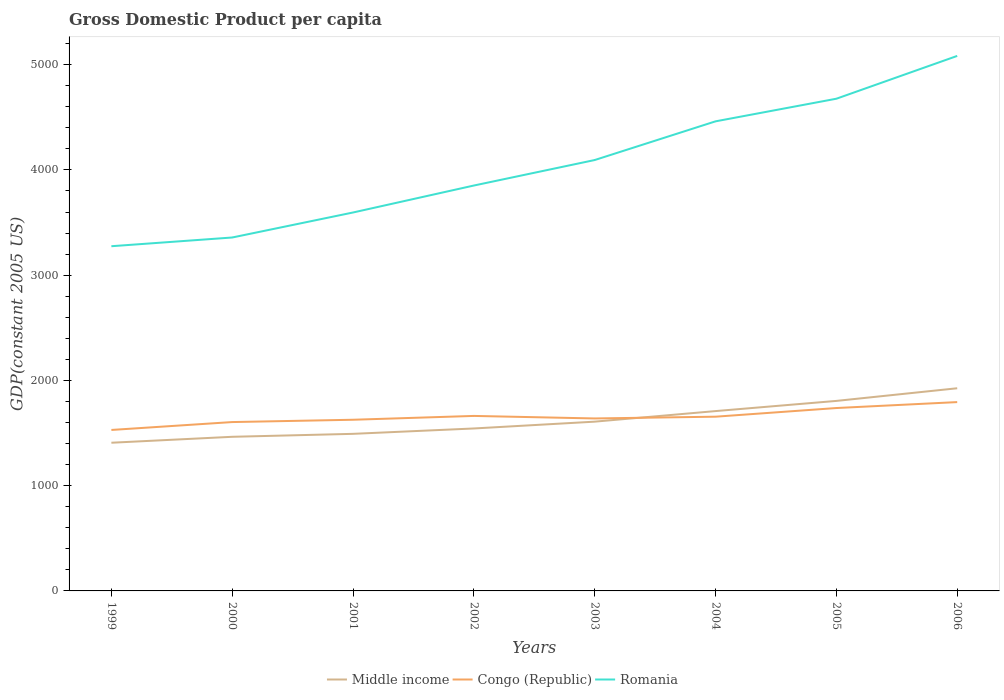Is the number of lines equal to the number of legend labels?
Your answer should be very brief. Yes. Across all years, what is the maximum GDP per capita in Middle income?
Ensure brevity in your answer.  1407.97. In which year was the GDP per capita in Congo (Republic) maximum?
Ensure brevity in your answer.  1999. What is the total GDP per capita in Congo (Republic) in the graph?
Provide a succinct answer. -264.66. What is the difference between the highest and the second highest GDP per capita in Middle income?
Ensure brevity in your answer.  517.51. What is the difference between the highest and the lowest GDP per capita in Middle income?
Offer a very short reply. 3. What is the difference between two consecutive major ticks on the Y-axis?
Provide a short and direct response. 1000. Are the values on the major ticks of Y-axis written in scientific E-notation?
Your answer should be compact. No. Does the graph contain any zero values?
Your answer should be very brief. No. Where does the legend appear in the graph?
Provide a short and direct response. Bottom center. How many legend labels are there?
Give a very brief answer. 3. What is the title of the graph?
Offer a very short reply. Gross Domestic Product per capita. Does "American Samoa" appear as one of the legend labels in the graph?
Provide a short and direct response. No. What is the label or title of the Y-axis?
Your answer should be compact. GDP(constant 2005 US). What is the GDP(constant 2005 US) in Middle income in 1999?
Your answer should be very brief. 1407.97. What is the GDP(constant 2005 US) of Congo (Republic) in 1999?
Your answer should be compact. 1529.32. What is the GDP(constant 2005 US) of Romania in 1999?
Make the answer very short. 3275.03. What is the GDP(constant 2005 US) of Middle income in 2000?
Your response must be concise. 1464.33. What is the GDP(constant 2005 US) in Congo (Republic) in 2000?
Offer a very short reply. 1604.28. What is the GDP(constant 2005 US) in Romania in 2000?
Give a very brief answer. 3357.81. What is the GDP(constant 2005 US) of Middle income in 2001?
Ensure brevity in your answer.  1492.45. What is the GDP(constant 2005 US) of Congo (Republic) in 2001?
Make the answer very short. 1626.26. What is the GDP(constant 2005 US) of Romania in 2001?
Your answer should be very brief. 3595.4. What is the GDP(constant 2005 US) in Middle income in 2002?
Offer a terse response. 1543.39. What is the GDP(constant 2005 US) in Congo (Republic) in 2002?
Make the answer very short. 1662.66. What is the GDP(constant 2005 US) in Romania in 2002?
Ensure brevity in your answer.  3851.67. What is the GDP(constant 2005 US) in Middle income in 2003?
Provide a succinct answer. 1608.23. What is the GDP(constant 2005 US) in Congo (Republic) in 2003?
Provide a short and direct response. 1638.6. What is the GDP(constant 2005 US) of Romania in 2003?
Your answer should be compact. 4093.86. What is the GDP(constant 2005 US) in Middle income in 2004?
Keep it short and to the point. 1708.59. What is the GDP(constant 2005 US) of Congo (Republic) in 2004?
Keep it short and to the point. 1655.31. What is the GDP(constant 2005 US) of Romania in 2004?
Offer a very short reply. 4461.4. What is the GDP(constant 2005 US) of Middle income in 2005?
Provide a succinct answer. 1805.33. What is the GDP(constant 2005 US) in Congo (Republic) in 2005?
Make the answer very short. 1737.61. What is the GDP(constant 2005 US) of Romania in 2005?
Give a very brief answer. 4676.32. What is the GDP(constant 2005 US) of Middle income in 2006?
Your response must be concise. 1925.47. What is the GDP(constant 2005 US) in Congo (Republic) in 2006?
Make the answer very short. 1793.98. What is the GDP(constant 2005 US) in Romania in 2006?
Offer a terse response. 5083.04. Across all years, what is the maximum GDP(constant 2005 US) of Middle income?
Provide a succinct answer. 1925.47. Across all years, what is the maximum GDP(constant 2005 US) in Congo (Republic)?
Offer a terse response. 1793.98. Across all years, what is the maximum GDP(constant 2005 US) of Romania?
Ensure brevity in your answer.  5083.04. Across all years, what is the minimum GDP(constant 2005 US) of Middle income?
Provide a succinct answer. 1407.97. Across all years, what is the minimum GDP(constant 2005 US) of Congo (Republic)?
Offer a terse response. 1529.32. Across all years, what is the minimum GDP(constant 2005 US) in Romania?
Make the answer very short. 3275.03. What is the total GDP(constant 2005 US) in Middle income in the graph?
Offer a very short reply. 1.30e+04. What is the total GDP(constant 2005 US) of Congo (Republic) in the graph?
Provide a short and direct response. 1.32e+04. What is the total GDP(constant 2005 US) of Romania in the graph?
Provide a succinct answer. 3.24e+04. What is the difference between the GDP(constant 2005 US) in Middle income in 1999 and that in 2000?
Your response must be concise. -56.36. What is the difference between the GDP(constant 2005 US) of Congo (Republic) in 1999 and that in 2000?
Offer a terse response. -74.96. What is the difference between the GDP(constant 2005 US) of Romania in 1999 and that in 2000?
Your answer should be compact. -82.78. What is the difference between the GDP(constant 2005 US) in Middle income in 1999 and that in 2001?
Offer a terse response. -84.48. What is the difference between the GDP(constant 2005 US) in Congo (Republic) in 1999 and that in 2001?
Ensure brevity in your answer.  -96.94. What is the difference between the GDP(constant 2005 US) in Romania in 1999 and that in 2001?
Your answer should be very brief. -320.38. What is the difference between the GDP(constant 2005 US) in Middle income in 1999 and that in 2002?
Ensure brevity in your answer.  -135.42. What is the difference between the GDP(constant 2005 US) of Congo (Republic) in 1999 and that in 2002?
Your response must be concise. -133.34. What is the difference between the GDP(constant 2005 US) in Romania in 1999 and that in 2002?
Ensure brevity in your answer.  -576.64. What is the difference between the GDP(constant 2005 US) in Middle income in 1999 and that in 2003?
Keep it short and to the point. -200.26. What is the difference between the GDP(constant 2005 US) in Congo (Republic) in 1999 and that in 2003?
Your answer should be compact. -109.28. What is the difference between the GDP(constant 2005 US) in Romania in 1999 and that in 2003?
Ensure brevity in your answer.  -818.84. What is the difference between the GDP(constant 2005 US) in Middle income in 1999 and that in 2004?
Make the answer very short. -300.63. What is the difference between the GDP(constant 2005 US) in Congo (Republic) in 1999 and that in 2004?
Provide a succinct answer. -125.99. What is the difference between the GDP(constant 2005 US) of Romania in 1999 and that in 2004?
Make the answer very short. -1186.37. What is the difference between the GDP(constant 2005 US) in Middle income in 1999 and that in 2005?
Provide a short and direct response. -397.36. What is the difference between the GDP(constant 2005 US) in Congo (Republic) in 1999 and that in 2005?
Your response must be concise. -208.29. What is the difference between the GDP(constant 2005 US) in Romania in 1999 and that in 2005?
Your response must be concise. -1401.29. What is the difference between the GDP(constant 2005 US) in Middle income in 1999 and that in 2006?
Your answer should be compact. -517.51. What is the difference between the GDP(constant 2005 US) of Congo (Republic) in 1999 and that in 2006?
Keep it short and to the point. -264.66. What is the difference between the GDP(constant 2005 US) of Romania in 1999 and that in 2006?
Your answer should be compact. -1808.01. What is the difference between the GDP(constant 2005 US) in Middle income in 2000 and that in 2001?
Keep it short and to the point. -28.12. What is the difference between the GDP(constant 2005 US) of Congo (Republic) in 2000 and that in 2001?
Give a very brief answer. -21.98. What is the difference between the GDP(constant 2005 US) of Romania in 2000 and that in 2001?
Make the answer very short. -237.59. What is the difference between the GDP(constant 2005 US) of Middle income in 2000 and that in 2002?
Your answer should be very brief. -79.06. What is the difference between the GDP(constant 2005 US) of Congo (Republic) in 2000 and that in 2002?
Your answer should be very brief. -58.38. What is the difference between the GDP(constant 2005 US) of Romania in 2000 and that in 2002?
Make the answer very short. -493.85. What is the difference between the GDP(constant 2005 US) in Middle income in 2000 and that in 2003?
Offer a very short reply. -143.9. What is the difference between the GDP(constant 2005 US) in Congo (Republic) in 2000 and that in 2003?
Make the answer very short. -34.32. What is the difference between the GDP(constant 2005 US) of Romania in 2000 and that in 2003?
Offer a very short reply. -736.05. What is the difference between the GDP(constant 2005 US) of Middle income in 2000 and that in 2004?
Keep it short and to the point. -244.26. What is the difference between the GDP(constant 2005 US) of Congo (Republic) in 2000 and that in 2004?
Ensure brevity in your answer.  -51.03. What is the difference between the GDP(constant 2005 US) of Romania in 2000 and that in 2004?
Your response must be concise. -1103.59. What is the difference between the GDP(constant 2005 US) in Middle income in 2000 and that in 2005?
Ensure brevity in your answer.  -341. What is the difference between the GDP(constant 2005 US) in Congo (Republic) in 2000 and that in 2005?
Offer a very short reply. -133.33. What is the difference between the GDP(constant 2005 US) in Romania in 2000 and that in 2005?
Make the answer very short. -1318.5. What is the difference between the GDP(constant 2005 US) of Middle income in 2000 and that in 2006?
Give a very brief answer. -461.14. What is the difference between the GDP(constant 2005 US) in Congo (Republic) in 2000 and that in 2006?
Keep it short and to the point. -189.7. What is the difference between the GDP(constant 2005 US) of Romania in 2000 and that in 2006?
Offer a very short reply. -1725.23. What is the difference between the GDP(constant 2005 US) in Middle income in 2001 and that in 2002?
Keep it short and to the point. -50.94. What is the difference between the GDP(constant 2005 US) in Congo (Republic) in 2001 and that in 2002?
Your answer should be compact. -36.4. What is the difference between the GDP(constant 2005 US) of Romania in 2001 and that in 2002?
Provide a short and direct response. -256.26. What is the difference between the GDP(constant 2005 US) in Middle income in 2001 and that in 2003?
Your answer should be compact. -115.78. What is the difference between the GDP(constant 2005 US) of Congo (Republic) in 2001 and that in 2003?
Ensure brevity in your answer.  -12.34. What is the difference between the GDP(constant 2005 US) in Romania in 2001 and that in 2003?
Provide a succinct answer. -498.46. What is the difference between the GDP(constant 2005 US) of Middle income in 2001 and that in 2004?
Provide a short and direct response. -216.15. What is the difference between the GDP(constant 2005 US) in Congo (Republic) in 2001 and that in 2004?
Your response must be concise. -29.05. What is the difference between the GDP(constant 2005 US) in Romania in 2001 and that in 2004?
Your answer should be very brief. -866. What is the difference between the GDP(constant 2005 US) in Middle income in 2001 and that in 2005?
Offer a terse response. -312.88. What is the difference between the GDP(constant 2005 US) of Congo (Republic) in 2001 and that in 2005?
Offer a terse response. -111.35. What is the difference between the GDP(constant 2005 US) in Romania in 2001 and that in 2005?
Provide a short and direct response. -1080.91. What is the difference between the GDP(constant 2005 US) in Middle income in 2001 and that in 2006?
Your answer should be very brief. -433.02. What is the difference between the GDP(constant 2005 US) in Congo (Republic) in 2001 and that in 2006?
Offer a terse response. -167.73. What is the difference between the GDP(constant 2005 US) of Romania in 2001 and that in 2006?
Your response must be concise. -1487.64. What is the difference between the GDP(constant 2005 US) of Middle income in 2002 and that in 2003?
Your response must be concise. -64.84. What is the difference between the GDP(constant 2005 US) of Congo (Republic) in 2002 and that in 2003?
Provide a short and direct response. 24.06. What is the difference between the GDP(constant 2005 US) of Romania in 2002 and that in 2003?
Ensure brevity in your answer.  -242.2. What is the difference between the GDP(constant 2005 US) of Middle income in 2002 and that in 2004?
Your answer should be very brief. -165.2. What is the difference between the GDP(constant 2005 US) in Congo (Republic) in 2002 and that in 2004?
Provide a succinct answer. 7.35. What is the difference between the GDP(constant 2005 US) of Romania in 2002 and that in 2004?
Give a very brief answer. -609.74. What is the difference between the GDP(constant 2005 US) of Middle income in 2002 and that in 2005?
Give a very brief answer. -261.94. What is the difference between the GDP(constant 2005 US) of Congo (Republic) in 2002 and that in 2005?
Provide a succinct answer. -74.95. What is the difference between the GDP(constant 2005 US) in Romania in 2002 and that in 2005?
Your answer should be very brief. -824.65. What is the difference between the GDP(constant 2005 US) in Middle income in 2002 and that in 2006?
Provide a succinct answer. -382.08. What is the difference between the GDP(constant 2005 US) in Congo (Republic) in 2002 and that in 2006?
Make the answer very short. -131.33. What is the difference between the GDP(constant 2005 US) in Romania in 2002 and that in 2006?
Ensure brevity in your answer.  -1231.38. What is the difference between the GDP(constant 2005 US) in Middle income in 2003 and that in 2004?
Your answer should be very brief. -100.36. What is the difference between the GDP(constant 2005 US) in Congo (Republic) in 2003 and that in 2004?
Your answer should be very brief. -16.71. What is the difference between the GDP(constant 2005 US) in Romania in 2003 and that in 2004?
Your answer should be compact. -367.54. What is the difference between the GDP(constant 2005 US) in Middle income in 2003 and that in 2005?
Make the answer very short. -197.1. What is the difference between the GDP(constant 2005 US) in Congo (Republic) in 2003 and that in 2005?
Your answer should be compact. -99.01. What is the difference between the GDP(constant 2005 US) of Romania in 2003 and that in 2005?
Your answer should be very brief. -582.45. What is the difference between the GDP(constant 2005 US) in Middle income in 2003 and that in 2006?
Give a very brief answer. -317.24. What is the difference between the GDP(constant 2005 US) of Congo (Republic) in 2003 and that in 2006?
Make the answer very short. -155.39. What is the difference between the GDP(constant 2005 US) in Romania in 2003 and that in 2006?
Your answer should be compact. -989.18. What is the difference between the GDP(constant 2005 US) in Middle income in 2004 and that in 2005?
Your response must be concise. -96.73. What is the difference between the GDP(constant 2005 US) in Congo (Republic) in 2004 and that in 2005?
Give a very brief answer. -82.3. What is the difference between the GDP(constant 2005 US) in Romania in 2004 and that in 2005?
Make the answer very short. -214.91. What is the difference between the GDP(constant 2005 US) of Middle income in 2004 and that in 2006?
Your answer should be compact. -216.88. What is the difference between the GDP(constant 2005 US) in Congo (Republic) in 2004 and that in 2006?
Keep it short and to the point. -138.68. What is the difference between the GDP(constant 2005 US) in Romania in 2004 and that in 2006?
Ensure brevity in your answer.  -621.64. What is the difference between the GDP(constant 2005 US) of Middle income in 2005 and that in 2006?
Your answer should be compact. -120.14. What is the difference between the GDP(constant 2005 US) of Congo (Republic) in 2005 and that in 2006?
Give a very brief answer. -56.37. What is the difference between the GDP(constant 2005 US) of Romania in 2005 and that in 2006?
Provide a succinct answer. -406.73. What is the difference between the GDP(constant 2005 US) of Middle income in 1999 and the GDP(constant 2005 US) of Congo (Republic) in 2000?
Offer a very short reply. -196.31. What is the difference between the GDP(constant 2005 US) of Middle income in 1999 and the GDP(constant 2005 US) of Romania in 2000?
Your response must be concise. -1949.85. What is the difference between the GDP(constant 2005 US) of Congo (Republic) in 1999 and the GDP(constant 2005 US) of Romania in 2000?
Offer a very short reply. -1828.49. What is the difference between the GDP(constant 2005 US) in Middle income in 1999 and the GDP(constant 2005 US) in Congo (Republic) in 2001?
Your answer should be very brief. -218.29. What is the difference between the GDP(constant 2005 US) in Middle income in 1999 and the GDP(constant 2005 US) in Romania in 2001?
Your answer should be compact. -2187.44. What is the difference between the GDP(constant 2005 US) of Congo (Republic) in 1999 and the GDP(constant 2005 US) of Romania in 2001?
Provide a short and direct response. -2066.08. What is the difference between the GDP(constant 2005 US) of Middle income in 1999 and the GDP(constant 2005 US) of Congo (Republic) in 2002?
Keep it short and to the point. -254.69. What is the difference between the GDP(constant 2005 US) in Middle income in 1999 and the GDP(constant 2005 US) in Romania in 2002?
Ensure brevity in your answer.  -2443.7. What is the difference between the GDP(constant 2005 US) of Congo (Republic) in 1999 and the GDP(constant 2005 US) of Romania in 2002?
Ensure brevity in your answer.  -2322.35. What is the difference between the GDP(constant 2005 US) in Middle income in 1999 and the GDP(constant 2005 US) in Congo (Republic) in 2003?
Keep it short and to the point. -230.63. What is the difference between the GDP(constant 2005 US) of Middle income in 1999 and the GDP(constant 2005 US) of Romania in 2003?
Provide a succinct answer. -2685.9. What is the difference between the GDP(constant 2005 US) of Congo (Republic) in 1999 and the GDP(constant 2005 US) of Romania in 2003?
Provide a succinct answer. -2564.54. What is the difference between the GDP(constant 2005 US) in Middle income in 1999 and the GDP(constant 2005 US) in Congo (Republic) in 2004?
Your answer should be very brief. -247.34. What is the difference between the GDP(constant 2005 US) of Middle income in 1999 and the GDP(constant 2005 US) of Romania in 2004?
Offer a terse response. -3053.44. What is the difference between the GDP(constant 2005 US) of Congo (Republic) in 1999 and the GDP(constant 2005 US) of Romania in 2004?
Keep it short and to the point. -2932.08. What is the difference between the GDP(constant 2005 US) in Middle income in 1999 and the GDP(constant 2005 US) in Congo (Republic) in 2005?
Provide a succinct answer. -329.65. What is the difference between the GDP(constant 2005 US) of Middle income in 1999 and the GDP(constant 2005 US) of Romania in 2005?
Your response must be concise. -3268.35. What is the difference between the GDP(constant 2005 US) in Congo (Republic) in 1999 and the GDP(constant 2005 US) in Romania in 2005?
Keep it short and to the point. -3147. What is the difference between the GDP(constant 2005 US) in Middle income in 1999 and the GDP(constant 2005 US) in Congo (Republic) in 2006?
Offer a very short reply. -386.02. What is the difference between the GDP(constant 2005 US) in Middle income in 1999 and the GDP(constant 2005 US) in Romania in 2006?
Provide a succinct answer. -3675.08. What is the difference between the GDP(constant 2005 US) in Congo (Republic) in 1999 and the GDP(constant 2005 US) in Romania in 2006?
Ensure brevity in your answer.  -3553.72. What is the difference between the GDP(constant 2005 US) of Middle income in 2000 and the GDP(constant 2005 US) of Congo (Republic) in 2001?
Your response must be concise. -161.93. What is the difference between the GDP(constant 2005 US) in Middle income in 2000 and the GDP(constant 2005 US) in Romania in 2001?
Provide a short and direct response. -2131.07. What is the difference between the GDP(constant 2005 US) of Congo (Republic) in 2000 and the GDP(constant 2005 US) of Romania in 2001?
Provide a succinct answer. -1991.12. What is the difference between the GDP(constant 2005 US) in Middle income in 2000 and the GDP(constant 2005 US) in Congo (Republic) in 2002?
Offer a terse response. -198.33. What is the difference between the GDP(constant 2005 US) in Middle income in 2000 and the GDP(constant 2005 US) in Romania in 2002?
Make the answer very short. -2387.34. What is the difference between the GDP(constant 2005 US) of Congo (Republic) in 2000 and the GDP(constant 2005 US) of Romania in 2002?
Your answer should be very brief. -2247.39. What is the difference between the GDP(constant 2005 US) in Middle income in 2000 and the GDP(constant 2005 US) in Congo (Republic) in 2003?
Give a very brief answer. -174.27. What is the difference between the GDP(constant 2005 US) of Middle income in 2000 and the GDP(constant 2005 US) of Romania in 2003?
Your response must be concise. -2629.53. What is the difference between the GDP(constant 2005 US) in Congo (Republic) in 2000 and the GDP(constant 2005 US) in Romania in 2003?
Keep it short and to the point. -2489.58. What is the difference between the GDP(constant 2005 US) in Middle income in 2000 and the GDP(constant 2005 US) in Congo (Republic) in 2004?
Keep it short and to the point. -190.98. What is the difference between the GDP(constant 2005 US) of Middle income in 2000 and the GDP(constant 2005 US) of Romania in 2004?
Provide a succinct answer. -2997.07. What is the difference between the GDP(constant 2005 US) of Congo (Republic) in 2000 and the GDP(constant 2005 US) of Romania in 2004?
Offer a very short reply. -2857.12. What is the difference between the GDP(constant 2005 US) in Middle income in 2000 and the GDP(constant 2005 US) in Congo (Republic) in 2005?
Your answer should be very brief. -273.28. What is the difference between the GDP(constant 2005 US) in Middle income in 2000 and the GDP(constant 2005 US) in Romania in 2005?
Provide a short and direct response. -3211.99. What is the difference between the GDP(constant 2005 US) in Congo (Republic) in 2000 and the GDP(constant 2005 US) in Romania in 2005?
Your answer should be compact. -3072.04. What is the difference between the GDP(constant 2005 US) in Middle income in 2000 and the GDP(constant 2005 US) in Congo (Republic) in 2006?
Ensure brevity in your answer.  -329.66. What is the difference between the GDP(constant 2005 US) in Middle income in 2000 and the GDP(constant 2005 US) in Romania in 2006?
Ensure brevity in your answer.  -3618.71. What is the difference between the GDP(constant 2005 US) of Congo (Republic) in 2000 and the GDP(constant 2005 US) of Romania in 2006?
Offer a terse response. -3478.76. What is the difference between the GDP(constant 2005 US) in Middle income in 2001 and the GDP(constant 2005 US) in Congo (Republic) in 2002?
Your answer should be compact. -170.21. What is the difference between the GDP(constant 2005 US) in Middle income in 2001 and the GDP(constant 2005 US) in Romania in 2002?
Provide a short and direct response. -2359.22. What is the difference between the GDP(constant 2005 US) in Congo (Republic) in 2001 and the GDP(constant 2005 US) in Romania in 2002?
Provide a succinct answer. -2225.41. What is the difference between the GDP(constant 2005 US) of Middle income in 2001 and the GDP(constant 2005 US) of Congo (Republic) in 2003?
Offer a terse response. -146.15. What is the difference between the GDP(constant 2005 US) of Middle income in 2001 and the GDP(constant 2005 US) of Romania in 2003?
Keep it short and to the point. -2601.41. What is the difference between the GDP(constant 2005 US) in Congo (Republic) in 2001 and the GDP(constant 2005 US) in Romania in 2003?
Your answer should be compact. -2467.6. What is the difference between the GDP(constant 2005 US) in Middle income in 2001 and the GDP(constant 2005 US) in Congo (Republic) in 2004?
Offer a terse response. -162.86. What is the difference between the GDP(constant 2005 US) of Middle income in 2001 and the GDP(constant 2005 US) of Romania in 2004?
Provide a short and direct response. -2968.95. What is the difference between the GDP(constant 2005 US) in Congo (Republic) in 2001 and the GDP(constant 2005 US) in Romania in 2004?
Your response must be concise. -2835.14. What is the difference between the GDP(constant 2005 US) of Middle income in 2001 and the GDP(constant 2005 US) of Congo (Republic) in 2005?
Give a very brief answer. -245.16. What is the difference between the GDP(constant 2005 US) of Middle income in 2001 and the GDP(constant 2005 US) of Romania in 2005?
Keep it short and to the point. -3183.87. What is the difference between the GDP(constant 2005 US) in Congo (Republic) in 2001 and the GDP(constant 2005 US) in Romania in 2005?
Keep it short and to the point. -3050.06. What is the difference between the GDP(constant 2005 US) of Middle income in 2001 and the GDP(constant 2005 US) of Congo (Republic) in 2006?
Make the answer very short. -301.54. What is the difference between the GDP(constant 2005 US) in Middle income in 2001 and the GDP(constant 2005 US) in Romania in 2006?
Provide a short and direct response. -3590.59. What is the difference between the GDP(constant 2005 US) of Congo (Republic) in 2001 and the GDP(constant 2005 US) of Romania in 2006?
Your response must be concise. -3456.78. What is the difference between the GDP(constant 2005 US) in Middle income in 2002 and the GDP(constant 2005 US) in Congo (Republic) in 2003?
Offer a very short reply. -95.21. What is the difference between the GDP(constant 2005 US) of Middle income in 2002 and the GDP(constant 2005 US) of Romania in 2003?
Provide a succinct answer. -2550.47. What is the difference between the GDP(constant 2005 US) of Congo (Republic) in 2002 and the GDP(constant 2005 US) of Romania in 2003?
Offer a terse response. -2431.2. What is the difference between the GDP(constant 2005 US) in Middle income in 2002 and the GDP(constant 2005 US) in Congo (Republic) in 2004?
Your response must be concise. -111.92. What is the difference between the GDP(constant 2005 US) of Middle income in 2002 and the GDP(constant 2005 US) of Romania in 2004?
Keep it short and to the point. -2918.01. What is the difference between the GDP(constant 2005 US) of Congo (Republic) in 2002 and the GDP(constant 2005 US) of Romania in 2004?
Ensure brevity in your answer.  -2798.74. What is the difference between the GDP(constant 2005 US) of Middle income in 2002 and the GDP(constant 2005 US) of Congo (Republic) in 2005?
Your answer should be very brief. -194.22. What is the difference between the GDP(constant 2005 US) in Middle income in 2002 and the GDP(constant 2005 US) in Romania in 2005?
Ensure brevity in your answer.  -3132.92. What is the difference between the GDP(constant 2005 US) in Congo (Republic) in 2002 and the GDP(constant 2005 US) in Romania in 2005?
Your answer should be compact. -3013.66. What is the difference between the GDP(constant 2005 US) of Middle income in 2002 and the GDP(constant 2005 US) of Congo (Republic) in 2006?
Provide a succinct answer. -250.59. What is the difference between the GDP(constant 2005 US) of Middle income in 2002 and the GDP(constant 2005 US) of Romania in 2006?
Make the answer very short. -3539.65. What is the difference between the GDP(constant 2005 US) in Congo (Republic) in 2002 and the GDP(constant 2005 US) in Romania in 2006?
Make the answer very short. -3420.38. What is the difference between the GDP(constant 2005 US) in Middle income in 2003 and the GDP(constant 2005 US) in Congo (Republic) in 2004?
Keep it short and to the point. -47.08. What is the difference between the GDP(constant 2005 US) in Middle income in 2003 and the GDP(constant 2005 US) in Romania in 2004?
Offer a terse response. -2853.17. What is the difference between the GDP(constant 2005 US) of Congo (Republic) in 2003 and the GDP(constant 2005 US) of Romania in 2004?
Keep it short and to the point. -2822.8. What is the difference between the GDP(constant 2005 US) of Middle income in 2003 and the GDP(constant 2005 US) of Congo (Republic) in 2005?
Your response must be concise. -129.38. What is the difference between the GDP(constant 2005 US) of Middle income in 2003 and the GDP(constant 2005 US) of Romania in 2005?
Make the answer very short. -3068.08. What is the difference between the GDP(constant 2005 US) in Congo (Republic) in 2003 and the GDP(constant 2005 US) in Romania in 2005?
Provide a succinct answer. -3037.72. What is the difference between the GDP(constant 2005 US) of Middle income in 2003 and the GDP(constant 2005 US) of Congo (Republic) in 2006?
Your answer should be compact. -185.75. What is the difference between the GDP(constant 2005 US) in Middle income in 2003 and the GDP(constant 2005 US) in Romania in 2006?
Ensure brevity in your answer.  -3474.81. What is the difference between the GDP(constant 2005 US) of Congo (Republic) in 2003 and the GDP(constant 2005 US) of Romania in 2006?
Provide a short and direct response. -3444.44. What is the difference between the GDP(constant 2005 US) in Middle income in 2004 and the GDP(constant 2005 US) in Congo (Republic) in 2005?
Offer a very short reply. -29.02. What is the difference between the GDP(constant 2005 US) in Middle income in 2004 and the GDP(constant 2005 US) in Romania in 2005?
Your answer should be very brief. -2967.72. What is the difference between the GDP(constant 2005 US) in Congo (Republic) in 2004 and the GDP(constant 2005 US) in Romania in 2005?
Offer a very short reply. -3021.01. What is the difference between the GDP(constant 2005 US) in Middle income in 2004 and the GDP(constant 2005 US) in Congo (Republic) in 2006?
Ensure brevity in your answer.  -85.39. What is the difference between the GDP(constant 2005 US) in Middle income in 2004 and the GDP(constant 2005 US) in Romania in 2006?
Your response must be concise. -3374.45. What is the difference between the GDP(constant 2005 US) in Congo (Republic) in 2004 and the GDP(constant 2005 US) in Romania in 2006?
Ensure brevity in your answer.  -3427.73. What is the difference between the GDP(constant 2005 US) in Middle income in 2005 and the GDP(constant 2005 US) in Congo (Republic) in 2006?
Your answer should be compact. 11.34. What is the difference between the GDP(constant 2005 US) of Middle income in 2005 and the GDP(constant 2005 US) of Romania in 2006?
Give a very brief answer. -3277.71. What is the difference between the GDP(constant 2005 US) in Congo (Republic) in 2005 and the GDP(constant 2005 US) in Romania in 2006?
Provide a short and direct response. -3345.43. What is the average GDP(constant 2005 US) of Middle income per year?
Ensure brevity in your answer.  1619.47. What is the average GDP(constant 2005 US) of Congo (Republic) per year?
Offer a very short reply. 1656. What is the average GDP(constant 2005 US) of Romania per year?
Your response must be concise. 4049.32. In the year 1999, what is the difference between the GDP(constant 2005 US) of Middle income and GDP(constant 2005 US) of Congo (Republic)?
Give a very brief answer. -121.35. In the year 1999, what is the difference between the GDP(constant 2005 US) of Middle income and GDP(constant 2005 US) of Romania?
Give a very brief answer. -1867.06. In the year 1999, what is the difference between the GDP(constant 2005 US) in Congo (Republic) and GDP(constant 2005 US) in Romania?
Your response must be concise. -1745.71. In the year 2000, what is the difference between the GDP(constant 2005 US) in Middle income and GDP(constant 2005 US) in Congo (Republic)?
Keep it short and to the point. -139.95. In the year 2000, what is the difference between the GDP(constant 2005 US) in Middle income and GDP(constant 2005 US) in Romania?
Provide a short and direct response. -1893.48. In the year 2000, what is the difference between the GDP(constant 2005 US) in Congo (Republic) and GDP(constant 2005 US) in Romania?
Provide a short and direct response. -1753.53. In the year 2001, what is the difference between the GDP(constant 2005 US) of Middle income and GDP(constant 2005 US) of Congo (Republic)?
Your response must be concise. -133.81. In the year 2001, what is the difference between the GDP(constant 2005 US) of Middle income and GDP(constant 2005 US) of Romania?
Offer a terse response. -2102.95. In the year 2001, what is the difference between the GDP(constant 2005 US) in Congo (Republic) and GDP(constant 2005 US) in Romania?
Make the answer very short. -1969.15. In the year 2002, what is the difference between the GDP(constant 2005 US) of Middle income and GDP(constant 2005 US) of Congo (Republic)?
Make the answer very short. -119.27. In the year 2002, what is the difference between the GDP(constant 2005 US) of Middle income and GDP(constant 2005 US) of Romania?
Make the answer very short. -2308.27. In the year 2002, what is the difference between the GDP(constant 2005 US) of Congo (Republic) and GDP(constant 2005 US) of Romania?
Your answer should be very brief. -2189.01. In the year 2003, what is the difference between the GDP(constant 2005 US) in Middle income and GDP(constant 2005 US) in Congo (Republic)?
Ensure brevity in your answer.  -30.37. In the year 2003, what is the difference between the GDP(constant 2005 US) in Middle income and GDP(constant 2005 US) in Romania?
Make the answer very short. -2485.63. In the year 2003, what is the difference between the GDP(constant 2005 US) of Congo (Republic) and GDP(constant 2005 US) of Romania?
Offer a very short reply. -2455.26. In the year 2004, what is the difference between the GDP(constant 2005 US) in Middle income and GDP(constant 2005 US) in Congo (Republic)?
Keep it short and to the point. 53.29. In the year 2004, what is the difference between the GDP(constant 2005 US) in Middle income and GDP(constant 2005 US) in Romania?
Keep it short and to the point. -2752.81. In the year 2004, what is the difference between the GDP(constant 2005 US) of Congo (Republic) and GDP(constant 2005 US) of Romania?
Provide a succinct answer. -2806.09. In the year 2005, what is the difference between the GDP(constant 2005 US) in Middle income and GDP(constant 2005 US) in Congo (Republic)?
Provide a short and direct response. 67.72. In the year 2005, what is the difference between the GDP(constant 2005 US) in Middle income and GDP(constant 2005 US) in Romania?
Ensure brevity in your answer.  -2870.99. In the year 2005, what is the difference between the GDP(constant 2005 US) of Congo (Republic) and GDP(constant 2005 US) of Romania?
Make the answer very short. -2938.7. In the year 2006, what is the difference between the GDP(constant 2005 US) in Middle income and GDP(constant 2005 US) in Congo (Republic)?
Your answer should be very brief. 131.49. In the year 2006, what is the difference between the GDP(constant 2005 US) of Middle income and GDP(constant 2005 US) of Romania?
Give a very brief answer. -3157.57. In the year 2006, what is the difference between the GDP(constant 2005 US) in Congo (Republic) and GDP(constant 2005 US) in Romania?
Keep it short and to the point. -3289.06. What is the ratio of the GDP(constant 2005 US) in Middle income in 1999 to that in 2000?
Offer a very short reply. 0.96. What is the ratio of the GDP(constant 2005 US) in Congo (Republic) in 1999 to that in 2000?
Provide a short and direct response. 0.95. What is the ratio of the GDP(constant 2005 US) of Romania in 1999 to that in 2000?
Your answer should be compact. 0.98. What is the ratio of the GDP(constant 2005 US) of Middle income in 1999 to that in 2001?
Your response must be concise. 0.94. What is the ratio of the GDP(constant 2005 US) of Congo (Republic) in 1999 to that in 2001?
Offer a terse response. 0.94. What is the ratio of the GDP(constant 2005 US) in Romania in 1999 to that in 2001?
Provide a short and direct response. 0.91. What is the ratio of the GDP(constant 2005 US) in Middle income in 1999 to that in 2002?
Offer a terse response. 0.91. What is the ratio of the GDP(constant 2005 US) in Congo (Republic) in 1999 to that in 2002?
Make the answer very short. 0.92. What is the ratio of the GDP(constant 2005 US) in Romania in 1999 to that in 2002?
Keep it short and to the point. 0.85. What is the ratio of the GDP(constant 2005 US) of Middle income in 1999 to that in 2003?
Your response must be concise. 0.88. What is the ratio of the GDP(constant 2005 US) in Congo (Republic) in 1999 to that in 2003?
Your answer should be compact. 0.93. What is the ratio of the GDP(constant 2005 US) in Romania in 1999 to that in 2003?
Your answer should be very brief. 0.8. What is the ratio of the GDP(constant 2005 US) in Middle income in 1999 to that in 2004?
Give a very brief answer. 0.82. What is the ratio of the GDP(constant 2005 US) in Congo (Republic) in 1999 to that in 2004?
Keep it short and to the point. 0.92. What is the ratio of the GDP(constant 2005 US) in Romania in 1999 to that in 2004?
Your response must be concise. 0.73. What is the ratio of the GDP(constant 2005 US) in Middle income in 1999 to that in 2005?
Offer a terse response. 0.78. What is the ratio of the GDP(constant 2005 US) of Congo (Republic) in 1999 to that in 2005?
Your answer should be very brief. 0.88. What is the ratio of the GDP(constant 2005 US) of Romania in 1999 to that in 2005?
Keep it short and to the point. 0.7. What is the ratio of the GDP(constant 2005 US) of Middle income in 1999 to that in 2006?
Keep it short and to the point. 0.73. What is the ratio of the GDP(constant 2005 US) of Congo (Republic) in 1999 to that in 2006?
Your answer should be very brief. 0.85. What is the ratio of the GDP(constant 2005 US) in Romania in 1999 to that in 2006?
Offer a very short reply. 0.64. What is the ratio of the GDP(constant 2005 US) in Middle income in 2000 to that in 2001?
Provide a short and direct response. 0.98. What is the ratio of the GDP(constant 2005 US) in Congo (Republic) in 2000 to that in 2001?
Your response must be concise. 0.99. What is the ratio of the GDP(constant 2005 US) of Romania in 2000 to that in 2001?
Offer a terse response. 0.93. What is the ratio of the GDP(constant 2005 US) in Middle income in 2000 to that in 2002?
Offer a terse response. 0.95. What is the ratio of the GDP(constant 2005 US) of Congo (Republic) in 2000 to that in 2002?
Give a very brief answer. 0.96. What is the ratio of the GDP(constant 2005 US) of Romania in 2000 to that in 2002?
Ensure brevity in your answer.  0.87. What is the ratio of the GDP(constant 2005 US) of Middle income in 2000 to that in 2003?
Your response must be concise. 0.91. What is the ratio of the GDP(constant 2005 US) of Congo (Republic) in 2000 to that in 2003?
Your response must be concise. 0.98. What is the ratio of the GDP(constant 2005 US) in Romania in 2000 to that in 2003?
Ensure brevity in your answer.  0.82. What is the ratio of the GDP(constant 2005 US) of Middle income in 2000 to that in 2004?
Your response must be concise. 0.86. What is the ratio of the GDP(constant 2005 US) in Congo (Republic) in 2000 to that in 2004?
Offer a very short reply. 0.97. What is the ratio of the GDP(constant 2005 US) in Romania in 2000 to that in 2004?
Offer a terse response. 0.75. What is the ratio of the GDP(constant 2005 US) in Middle income in 2000 to that in 2005?
Make the answer very short. 0.81. What is the ratio of the GDP(constant 2005 US) of Congo (Republic) in 2000 to that in 2005?
Provide a succinct answer. 0.92. What is the ratio of the GDP(constant 2005 US) of Romania in 2000 to that in 2005?
Offer a very short reply. 0.72. What is the ratio of the GDP(constant 2005 US) in Middle income in 2000 to that in 2006?
Offer a terse response. 0.76. What is the ratio of the GDP(constant 2005 US) in Congo (Republic) in 2000 to that in 2006?
Make the answer very short. 0.89. What is the ratio of the GDP(constant 2005 US) of Romania in 2000 to that in 2006?
Give a very brief answer. 0.66. What is the ratio of the GDP(constant 2005 US) of Congo (Republic) in 2001 to that in 2002?
Provide a succinct answer. 0.98. What is the ratio of the GDP(constant 2005 US) in Romania in 2001 to that in 2002?
Provide a succinct answer. 0.93. What is the ratio of the GDP(constant 2005 US) of Middle income in 2001 to that in 2003?
Offer a terse response. 0.93. What is the ratio of the GDP(constant 2005 US) of Romania in 2001 to that in 2003?
Provide a succinct answer. 0.88. What is the ratio of the GDP(constant 2005 US) in Middle income in 2001 to that in 2004?
Make the answer very short. 0.87. What is the ratio of the GDP(constant 2005 US) in Congo (Republic) in 2001 to that in 2004?
Provide a succinct answer. 0.98. What is the ratio of the GDP(constant 2005 US) of Romania in 2001 to that in 2004?
Your answer should be very brief. 0.81. What is the ratio of the GDP(constant 2005 US) in Middle income in 2001 to that in 2005?
Offer a terse response. 0.83. What is the ratio of the GDP(constant 2005 US) of Congo (Republic) in 2001 to that in 2005?
Provide a succinct answer. 0.94. What is the ratio of the GDP(constant 2005 US) of Romania in 2001 to that in 2005?
Offer a very short reply. 0.77. What is the ratio of the GDP(constant 2005 US) of Middle income in 2001 to that in 2006?
Provide a short and direct response. 0.78. What is the ratio of the GDP(constant 2005 US) of Congo (Republic) in 2001 to that in 2006?
Give a very brief answer. 0.91. What is the ratio of the GDP(constant 2005 US) in Romania in 2001 to that in 2006?
Your response must be concise. 0.71. What is the ratio of the GDP(constant 2005 US) in Middle income in 2002 to that in 2003?
Your response must be concise. 0.96. What is the ratio of the GDP(constant 2005 US) in Congo (Republic) in 2002 to that in 2003?
Provide a short and direct response. 1.01. What is the ratio of the GDP(constant 2005 US) in Romania in 2002 to that in 2003?
Make the answer very short. 0.94. What is the ratio of the GDP(constant 2005 US) of Middle income in 2002 to that in 2004?
Make the answer very short. 0.9. What is the ratio of the GDP(constant 2005 US) of Congo (Republic) in 2002 to that in 2004?
Your answer should be very brief. 1. What is the ratio of the GDP(constant 2005 US) in Romania in 2002 to that in 2004?
Provide a short and direct response. 0.86. What is the ratio of the GDP(constant 2005 US) of Middle income in 2002 to that in 2005?
Offer a very short reply. 0.85. What is the ratio of the GDP(constant 2005 US) in Congo (Republic) in 2002 to that in 2005?
Provide a short and direct response. 0.96. What is the ratio of the GDP(constant 2005 US) of Romania in 2002 to that in 2005?
Keep it short and to the point. 0.82. What is the ratio of the GDP(constant 2005 US) of Middle income in 2002 to that in 2006?
Your response must be concise. 0.8. What is the ratio of the GDP(constant 2005 US) of Congo (Republic) in 2002 to that in 2006?
Your answer should be compact. 0.93. What is the ratio of the GDP(constant 2005 US) in Romania in 2002 to that in 2006?
Your response must be concise. 0.76. What is the ratio of the GDP(constant 2005 US) in Middle income in 2003 to that in 2004?
Your response must be concise. 0.94. What is the ratio of the GDP(constant 2005 US) in Congo (Republic) in 2003 to that in 2004?
Ensure brevity in your answer.  0.99. What is the ratio of the GDP(constant 2005 US) in Romania in 2003 to that in 2004?
Ensure brevity in your answer.  0.92. What is the ratio of the GDP(constant 2005 US) of Middle income in 2003 to that in 2005?
Give a very brief answer. 0.89. What is the ratio of the GDP(constant 2005 US) in Congo (Republic) in 2003 to that in 2005?
Your response must be concise. 0.94. What is the ratio of the GDP(constant 2005 US) in Romania in 2003 to that in 2005?
Provide a short and direct response. 0.88. What is the ratio of the GDP(constant 2005 US) in Middle income in 2003 to that in 2006?
Keep it short and to the point. 0.84. What is the ratio of the GDP(constant 2005 US) of Congo (Republic) in 2003 to that in 2006?
Keep it short and to the point. 0.91. What is the ratio of the GDP(constant 2005 US) in Romania in 2003 to that in 2006?
Provide a succinct answer. 0.81. What is the ratio of the GDP(constant 2005 US) of Middle income in 2004 to that in 2005?
Offer a very short reply. 0.95. What is the ratio of the GDP(constant 2005 US) in Congo (Republic) in 2004 to that in 2005?
Your answer should be very brief. 0.95. What is the ratio of the GDP(constant 2005 US) in Romania in 2004 to that in 2005?
Your response must be concise. 0.95. What is the ratio of the GDP(constant 2005 US) in Middle income in 2004 to that in 2006?
Your response must be concise. 0.89. What is the ratio of the GDP(constant 2005 US) of Congo (Republic) in 2004 to that in 2006?
Your response must be concise. 0.92. What is the ratio of the GDP(constant 2005 US) of Romania in 2004 to that in 2006?
Offer a terse response. 0.88. What is the ratio of the GDP(constant 2005 US) in Middle income in 2005 to that in 2006?
Your answer should be compact. 0.94. What is the ratio of the GDP(constant 2005 US) in Congo (Republic) in 2005 to that in 2006?
Give a very brief answer. 0.97. What is the difference between the highest and the second highest GDP(constant 2005 US) of Middle income?
Your answer should be very brief. 120.14. What is the difference between the highest and the second highest GDP(constant 2005 US) of Congo (Republic)?
Give a very brief answer. 56.37. What is the difference between the highest and the second highest GDP(constant 2005 US) in Romania?
Your answer should be compact. 406.73. What is the difference between the highest and the lowest GDP(constant 2005 US) of Middle income?
Your answer should be compact. 517.51. What is the difference between the highest and the lowest GDP(constant 2005 US) of Congo (Republic)?
Ensure brevity in your answer.  264.66. What is the difference between the highest and the lowest GDP(constant 2005 US) in Romania?
Offer a very short reply. 1808.01. 